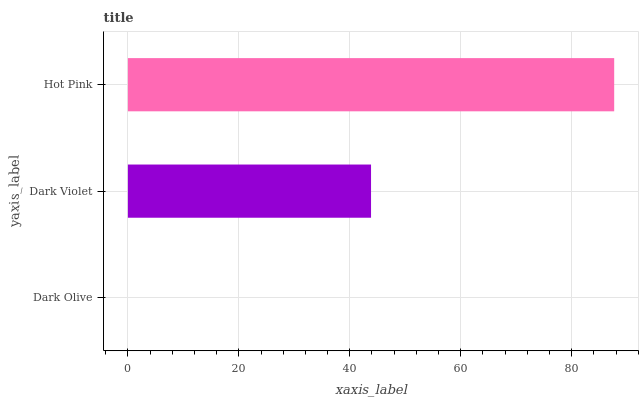Is Dark Olive the minimum?
Answer yes or no. Yes. Is Hot Pink the maximum?
Answer yes or no. Yes. Is Dark Violet the minimum?
Answer yes or no. No. Is Dark Violet the maximum?
Answer yes or no. No. Is Dark Violet greater than Dark Olive?
Answer yes or no. Yes. Is Dark Olive less than Dark Violet?
Answer yes or no. Yes. Is Dark Olive greater than Dark Violet?
Answer yes or no. No. Is Dark Violet less than Dark Olive?
Answer yes or no. No. Is Dark Violet the high median?
Answer yes or no. Yes. Is Dark Violet the low median?
Answer yes or no. Yes. Is Dark Olive the high median?
Answer yes or no. No. Is Dark Olive the low median?
Answer yes or no. No. 